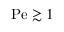<formula> <loc_0><loc_0><loc_500><loc_500>P e \gtrsim 1</formula> 